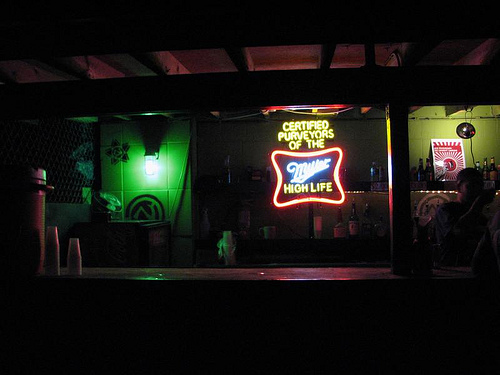<image>
Is the sign on the wall? Yes. Looking at the image, I can see the sign is positioned on top of the wall, with the wall providing support. 